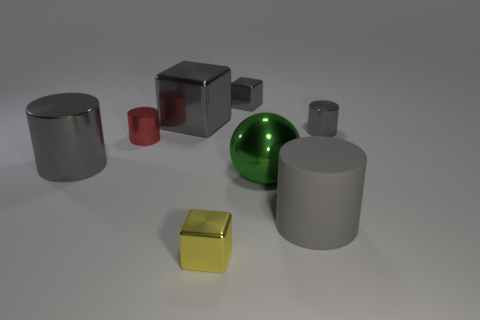Are there any other things that have the same size as the yellow metallic block?
Your answer should be very brief. Yes. Is the shape of the large green thing the same as the red thing?
Offer a very short reply. No. There is a gray cylinder that is left of the tiny cube that is behind the small yellow object; how big is it?
Make the answer very short. Large. There is another big object that is the same shape as the yellow shiny object; what color is it?
Keep it short and to the point. Gray. What number of big blocks have the same color as the rubber object?
Offer a terse response. 1. The red thing is what size?
Your response must be concise. Small. Is the size of the red cylinder the same as the green ball?
Give a very brief answer. No. There is a metal object that is both to the left of the large cube and in front of the red cylinder; what color is it?
Provide a short and direct response. Gray. How many tiny cubes have the same material as the large ball?
Ensure brevity in your answer.  2. How many big cyan rubber cubes are there?
Your answer should be compact. 0. 